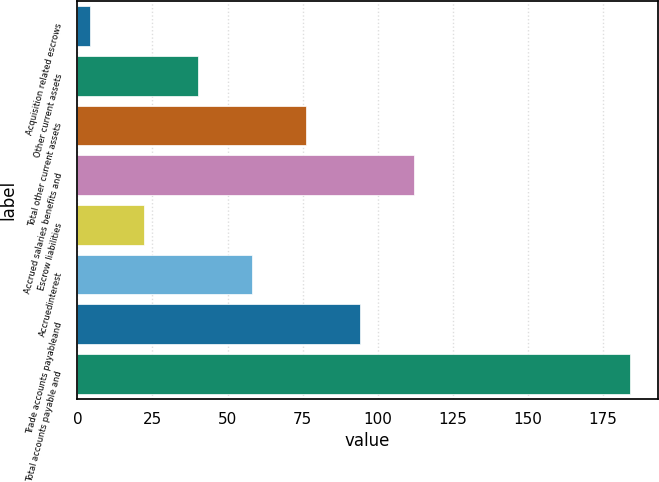Convert chart. <chart><loc_0><loc_0><loc_500><loc_500><bar_chart><fcel>Acquisition related escrows<fcel>Other current assets<fcel>Total other current assets<fcel>Accrued salaries benefits and<fcel>Escrow liabilities<fcel>Accruedinterest<fcel>Trade accounts payableand<fcel>Total accounts payable and<nl><fcel>4.1<fcel>40.08<fcel>76.06<fcel>112.04<fcel>22.09<fcel>58.07<fcel>94.05<fcel>184<nl></chart> 